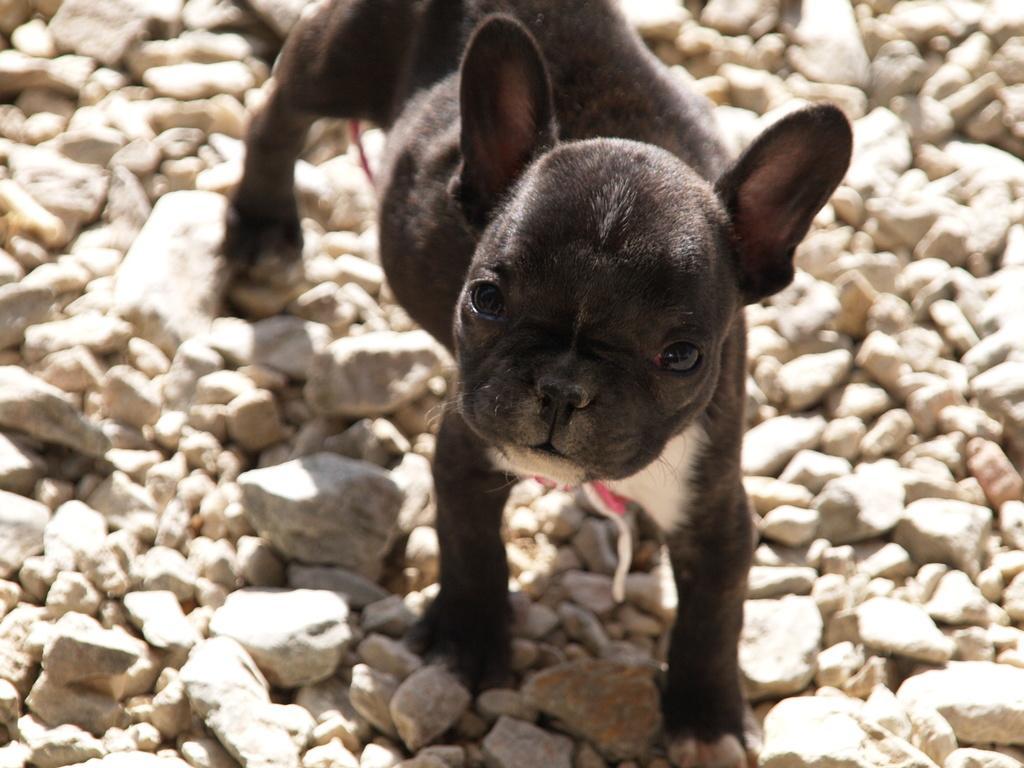In one or two sentences, can you explain what this image depicts? In this image we can see a black color dog on the stones. 